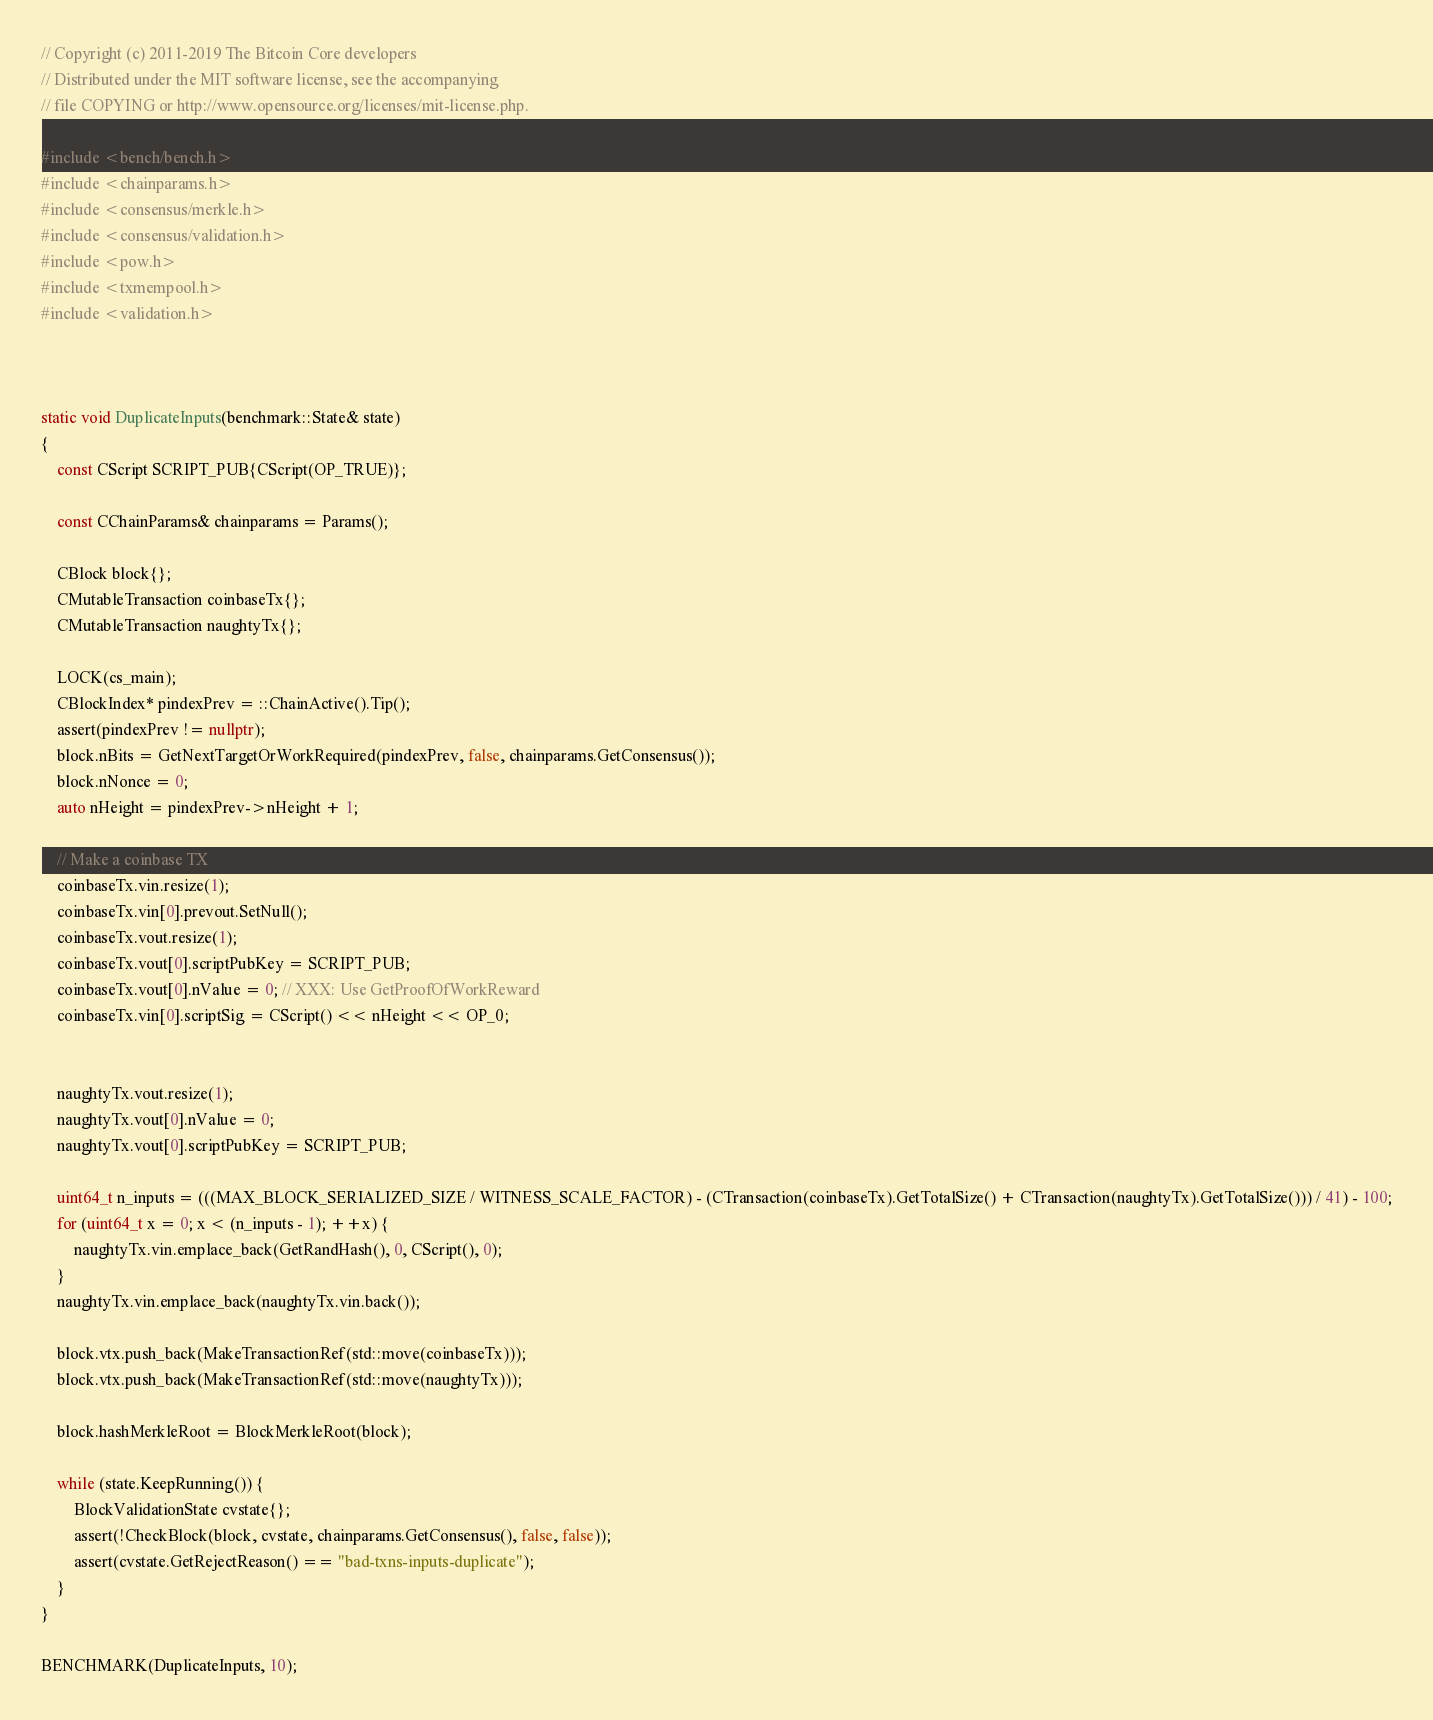<code> <loc_0><loc_0><loc_500><loc_500><_C++_>// Copyright (c) 2011-2019 The Bitcoin Core developers
// Distributed under the MIT software license, see the accompanying
// file COPYING or http://www.opensource.org/licenses/mit-license.php.

#include <bench/bench.h>
#include <chainparams.h>
#include <consensus/merkle.h>
#include <consensus/validation.h>
#include <pow.h>
#include <txmempool.h>
#include <validation.h>



static void DuplicateInputs(benchmark::State& state)
{
    const CScript SCRIPT_PUB{CScript(OP_TRUE)};

    const CChainParams& chainparams = Params();

    CBlock block{};
    CMutableTransaction coinbaseTx{};
    CMutableTransaction naughtyTx{};

    LOCK(cs_main);
    CBlockIndex* pindexPrev = ::ChainActive().Tip();
    assert(pindexPrev != nullptr);
    block.nBits = GetNextTargetOrWorkRequired(pindexPrev, false, chainparams.GetConsensus());
    block.nNonce = 0;
    auto nHeight = pindexPrev->nHeight + 1;

    // Make a coinbase TX
    coinbaseTx.vin.resize(1);
    coinbaseTx.vin[0].prevout.SetNull();
    coinbaseTx.vout.resize(1);
    coinbaseTx.vout[0].scriptPubKey = SCRIPT_PUB;
    coinbaseTx.vout[0].nValue = 0; // XXX: Use GetProofOfWorkReward
    coinbaseTx.vin[0].scriptSig = CScript() << nHeight << OP_0;


    naughtyTx.vout.resize(1);
    naughtyTx.vout[0].nValue = 0;
    naughtyTx.vout[0].scriptPubKey = SCRIPT_PUB;

    uint64_t n_inputs = (((MAX_BLOCK_SERIALIZED_SIZE / WITNESS_SCALE_FACTOR) - (CTransaction(coinbaseTx).GetTotalSize() + CTransaction(naughtyTx).GetTotalSize())) / 41) - 100;
    for (uint64_t x = 0; x < (n_inputs - 1); ++x) {
        naughtyTx.vin.emplace_back(GetRandHash(), 0, CScript(), 0);
    }
    naughtyTx.vin.emplace_back(naughtyTx.vin.back());

    block.vtx.push_back(MakeTransactionRef(std::move(coinbaseTx)));
    block.vtx.push_back(MakeTransactionRef(std::move(naughtyTx)));

    block.hashMerkleRoot = BlockMerkleRoot(block);

    while (state.KeepRunning()) {
        BlockValidationState cvstate{};
        assert(!CheckBlock(block, cvstate, chainparams.GetConsensus(), false, false));
        assert(cvstate.GetRejectReason() == "bad-txns-inputs-duplicate");
    }
}

BENCHMARK(DuplicateInputs, 10);
</code> 